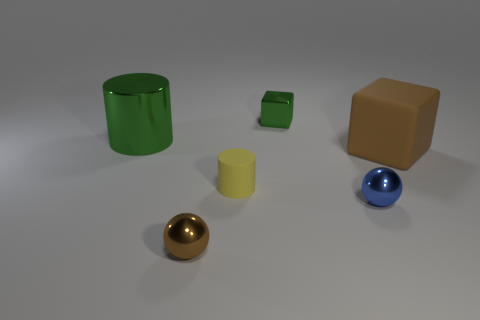Subtract 1 cylinders. How many cylinders are left? 1 Subtract all gray cubes. How many yellow cylinders are left? 1 Subtract all tiny metallic objects. Subtract all small green blocks. How many objects are left? 2 Add 1 spheres. How many spheres are left? 3 Add 2 brown balls. How many brown balls exist? 3 Add 3 purple shiny cylinders. How many objects exist? 9 Subtract all yellow cylinders. How many cylinders are left? 1 Subtract 0 yellow blocks. How many objects are left? 6 Subtract all cylinders. How many objects are left? 4 Subtract all green spheres. Subtract all red cubes. How many spheres are left? 2 